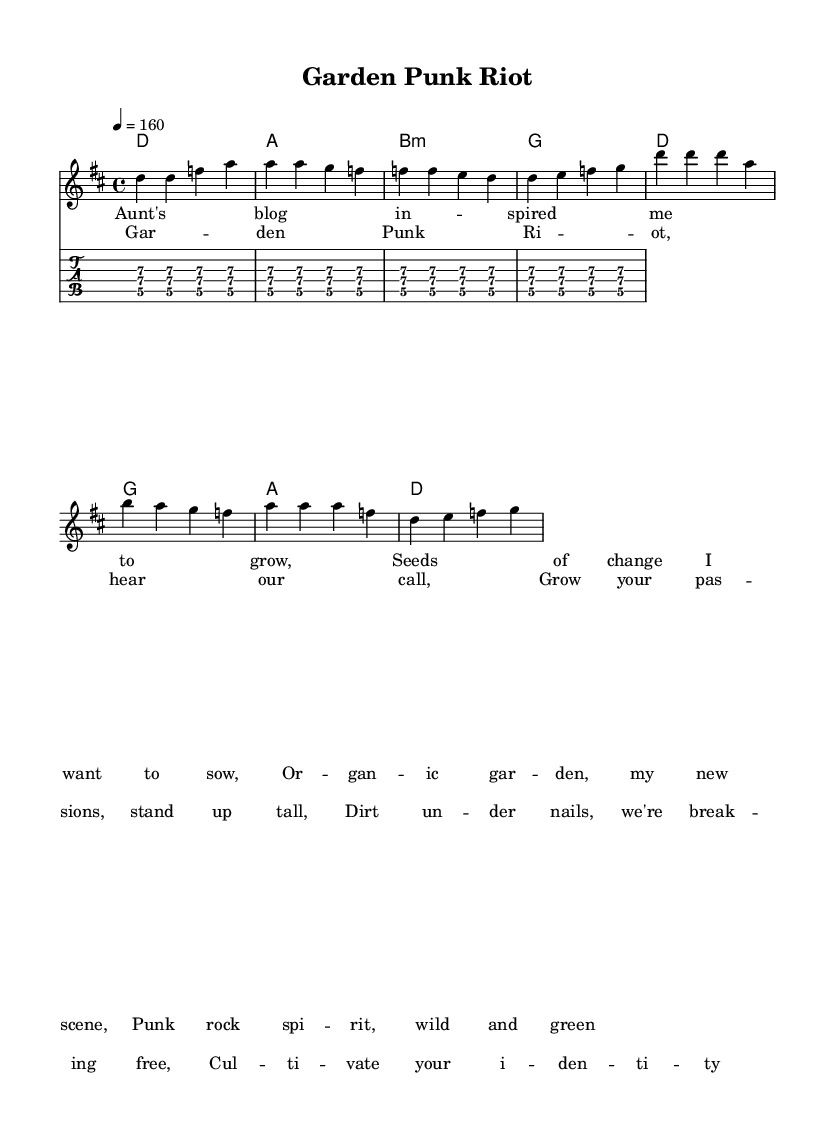What is the key signature of this music? The key signature is two sharps, which corresponds to the D major scale. The notes in the key signature are F sharp and C sharp.
Answer: D major What is the time signature of this piece? The time signature is indicated as 4 over 4, which means there are four beats in each measure and the quarter note gets one beat.
Answer: 4/4 What is the tempo marking for this piece? The tempo is marked as 4 equals 160, indicating the speed at which the piece should be played, with 160 beats per minute.
Answer: 160 How many measures are in the verse section? The verse section consists of four measures, as indicated by the grouped notes. Each measure contains four beats, and there are a total of four measures in the verse.
Answer: 4 Which chord follows the verse in the progression? After the verse, the chord progression moves to A major, indicated directly after the verse's D major chord.
Answer: A What is the main theme of the lyrics in this piece? The main theme of the lyrics centers around empowerment and self-expression, specifically through gardening as a metaphor for personal growth and identity.
Answer: Empowerment What punk element is reflected in the lyrics of this song? The lyrics reflect themes of rebellion and independence, common in punk music, by encouraging individuals to cultivate their passions and assert their identities.
Answer: Rebellion 